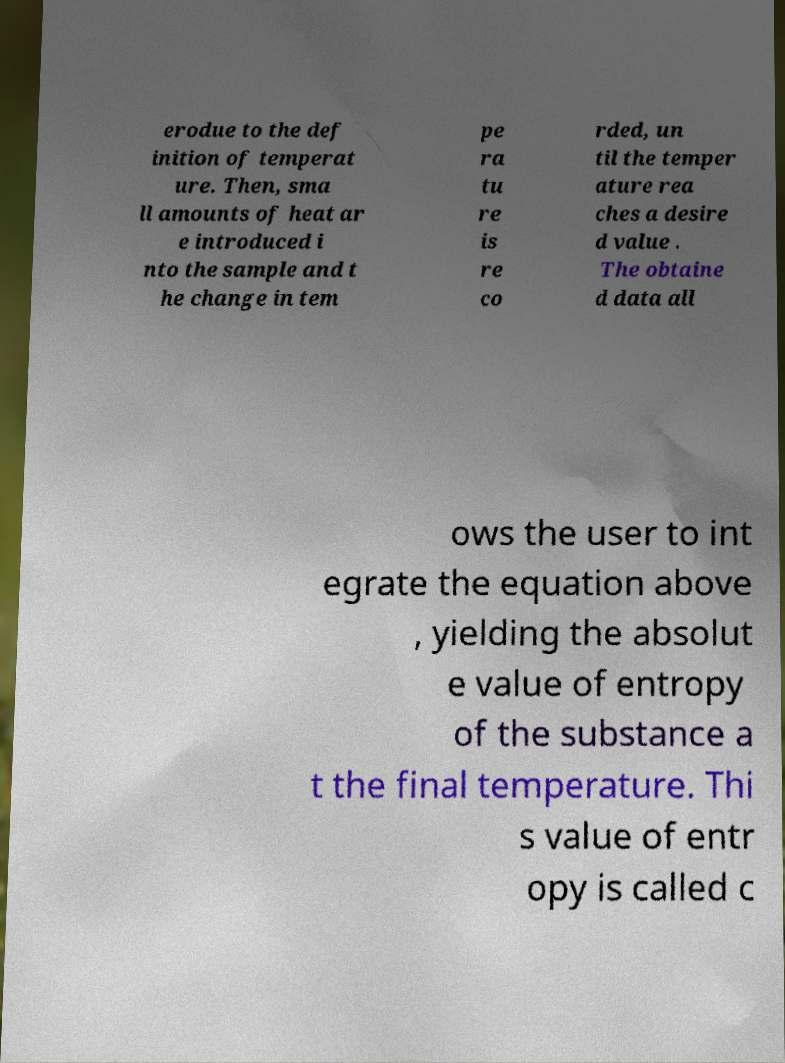For documentation purposes, I need the text within this image transcribed. Could you provide that? erodue to the def inition of temperat ure. Then, sma ll amounts of heat ar e introduced i nto the sample and t he change in tem pe ra tu re is re co rded, un til the temper ature rea ches a desire d value . The obtaine d data all ows the user to int egrate the equation above , yielding the absolut e value of entropy of the substance a t the final temperature. Thi s value of entr opy is called c 